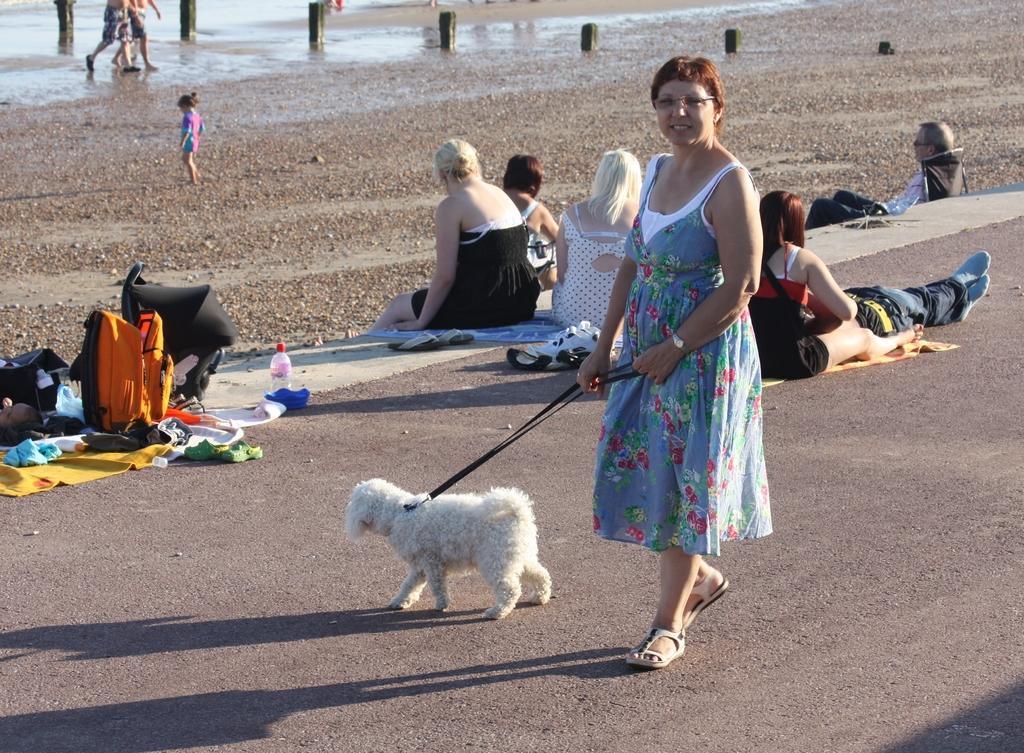Please provide a concise description of this image. In this image we can see a woman carrying a dog. There are many people sitting on the road, bags, bottles and water in the background. 